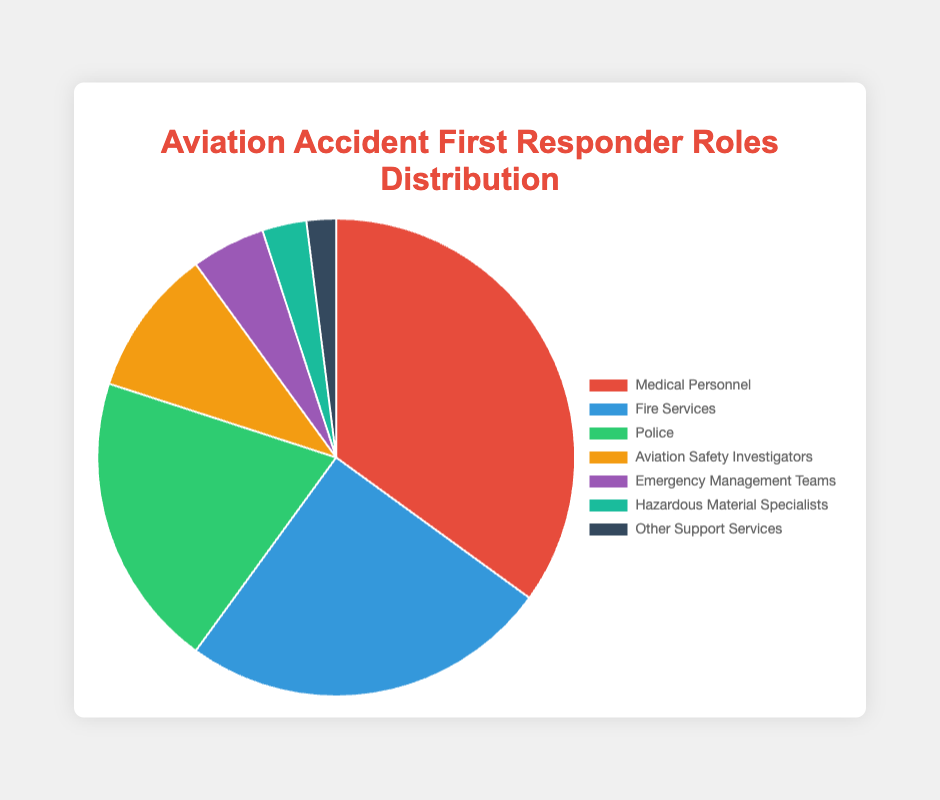What is the largest segment in the pie chart? The largest segment in the pie chart is visually represented by the largest area. By observing the size of the slices, the largest one corresponds to "Medical Personnel."
Answer: Medical Personnel Which segment represents the least amount of first responders? The smallest segment in the pie chart represents the least amount of first responders. This is visually the smallest slice, which corresponds to "Other Support Services."
Answer: Other Support Services What is the combined percentage of Police and Fire Services? To find the combined percentage, you add the individual percentages of the Police and Fire Services. Police is 20% and Fire Services is 25%. So, 20% + 25% = 45%.
Answer: 45% What is the difference in percentage points between Medical Personnel and Hazardous Material Specialists? To find the difference, subtract the percentage of Hazardous Material Specialists from that of Medical Personnel. Medical Personnel is 35%, and Hazardous Material Specialists are 3%. So, 35% - 3% = 32%.
Answer: 32% What group has exactly half the percentage of Medical Personnel? To find which group has exactly half the percentage of Medical Personnel (35%), compute 35% ÷ 2 = 17.5%. None of the groups have exactly 17.5%; however, "Police" is 20%, which is close and can be considered for ensuring the most significant match.
Answer: None Which segments combined make more than 50% of the total? Identify the segments whose combined percentages exceed 50%. Medical Personnel (35%) + Fire Services (25%) = 60% which is already more than 50%. So, Medical Personnel and Fire Services together exceed 50%.
Answer: Medical Personnel and Fire Services What color represents Aviation Safety Investigators? The pie chart uses colors to differentiate segments. By matching the sector to the label in the legend, Aviation Safety Investigators are represented by the color that matches their label's color, which is typically "orange/yellowish."
Answer: Orange/Yellowish How many roles make up less than 10% each? Count the number of segments where the individual percentages are less than 10%. These are Aviation Safety Investigators (10%), Emergency Management Teams (5%), Hazardous Material Specialists (3%), and Other Support Services (2%). So, 4 roles.
Answer: 4 What is the average percentage of all roles combined? To find the average, sum all the percentages and divide by the number of roles. The total is 35% + 25% + 20% + 10% + 5% + 3% + 2% = 100%. There are 7 roles, so the average is 100% ÷ 7 ≈ 14.29%.
Answer: ~14.29% Which role has a visual representation in the darkest color? Compare the colors of the segments and identify the darkest one. By matching that segment to the label in the legend, the darkest color is a very dark grey/blue, which corresponds to "Other Support Services."
Answer: Other Support Services 